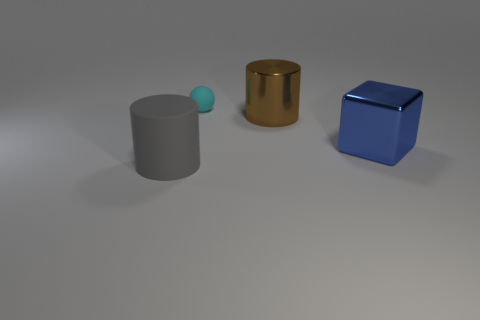What number of brown metal things are right of the tiny cyan matte ball that is behind the object that is on the right side of the brown shiny thing?
Make the answer very short. 1. Are there more cyan spheres than matte objects?
Your response must be concise. No. Do the brown metallic cylinder and the gray rubber cylinder have the same size?
Your answer should be compact. Yes. How many things are either gray cylinders or cyan balls?
Provide a succinct answer. 2. The matte thing behind the matte thing in front of the big cylinder right of the small rubber object is what shape?
Make the answer very short. Sphere. Is the material of the big cylinder that is right of the gray cylinder the same as the tiny cyan sphere on the left side of the blue cube?
Keep it short and to the point. No. What material is the other large brown object that is the same shape as the big matte thing?
Provide a succinct answer. Metal. Is there any other thing that has the same size as the cyan ball?
Your response must be concise. No. Do the matte object in front of the tiny rubber sphere and the big metal thing on the left side of the large block have the same shape?
Offer a terse response. Yes. Are there fewer large blue blocks on the left side of the gray rubber object than large blue metal things that are right of the brown cylinder?
Your answer should be compact. Yes. 